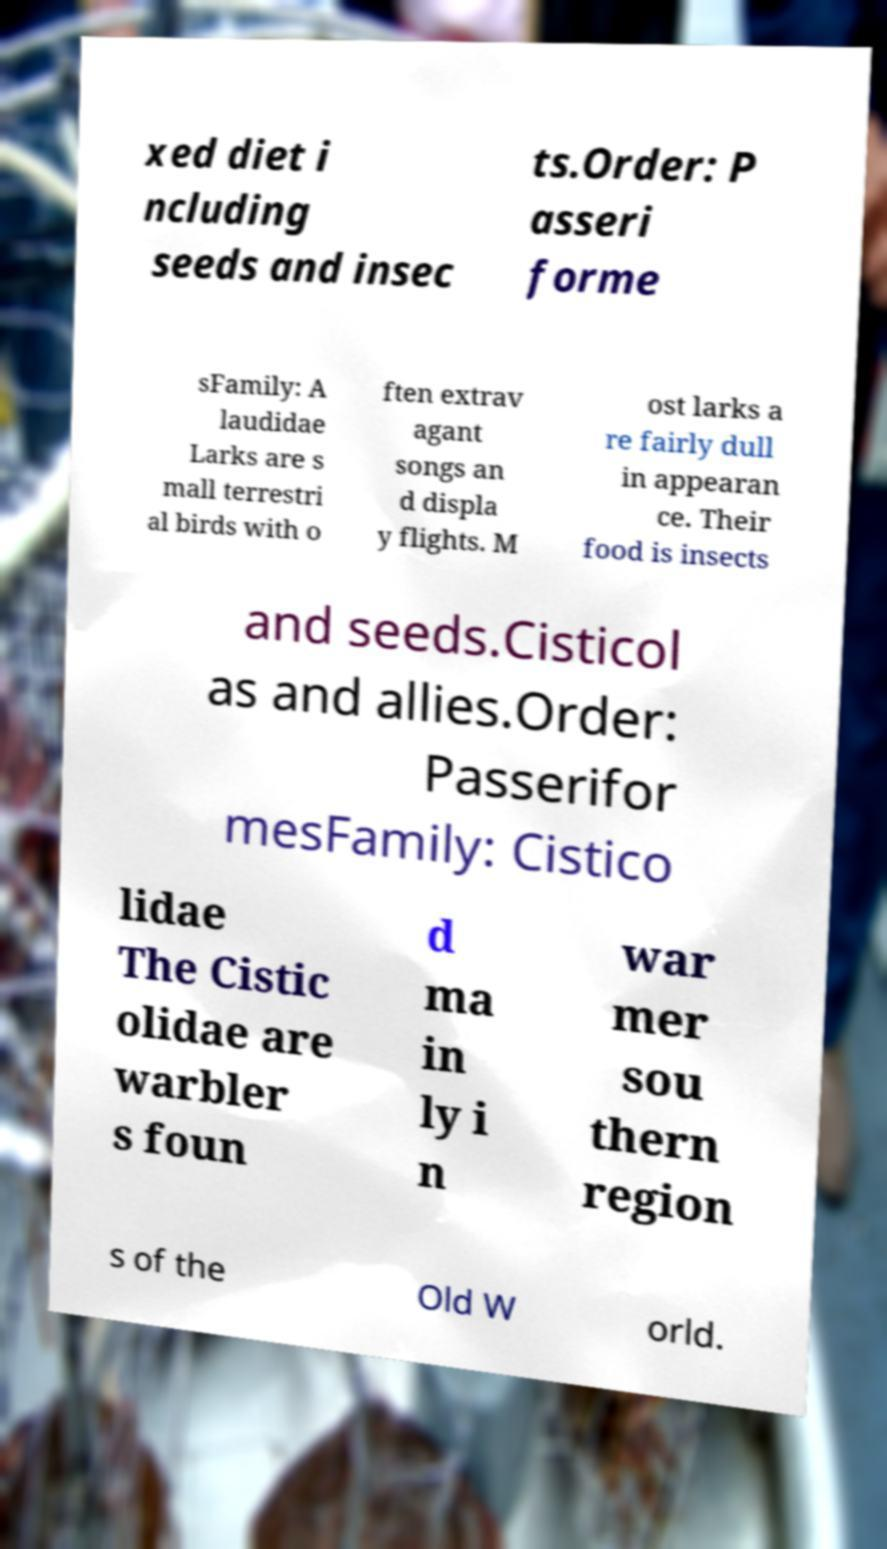Please identify and transcribe the text found in this image. xed diet i ncluding seeds and insec ts.Order: P asseri forme sFamily: A laudidae Larks are s mall terrestri al birds with o ften extrav agant songs an d displa y flights. M ost larks a re fairly dull in appearan ce. Their food is insects and seeds.Cisticol as and allies.Order: Passerifor mesFamily: Cistico lidae The Cistic olidae are warbler s foun d ma in ly i n war mer sou thern region s of the Old W orld. 